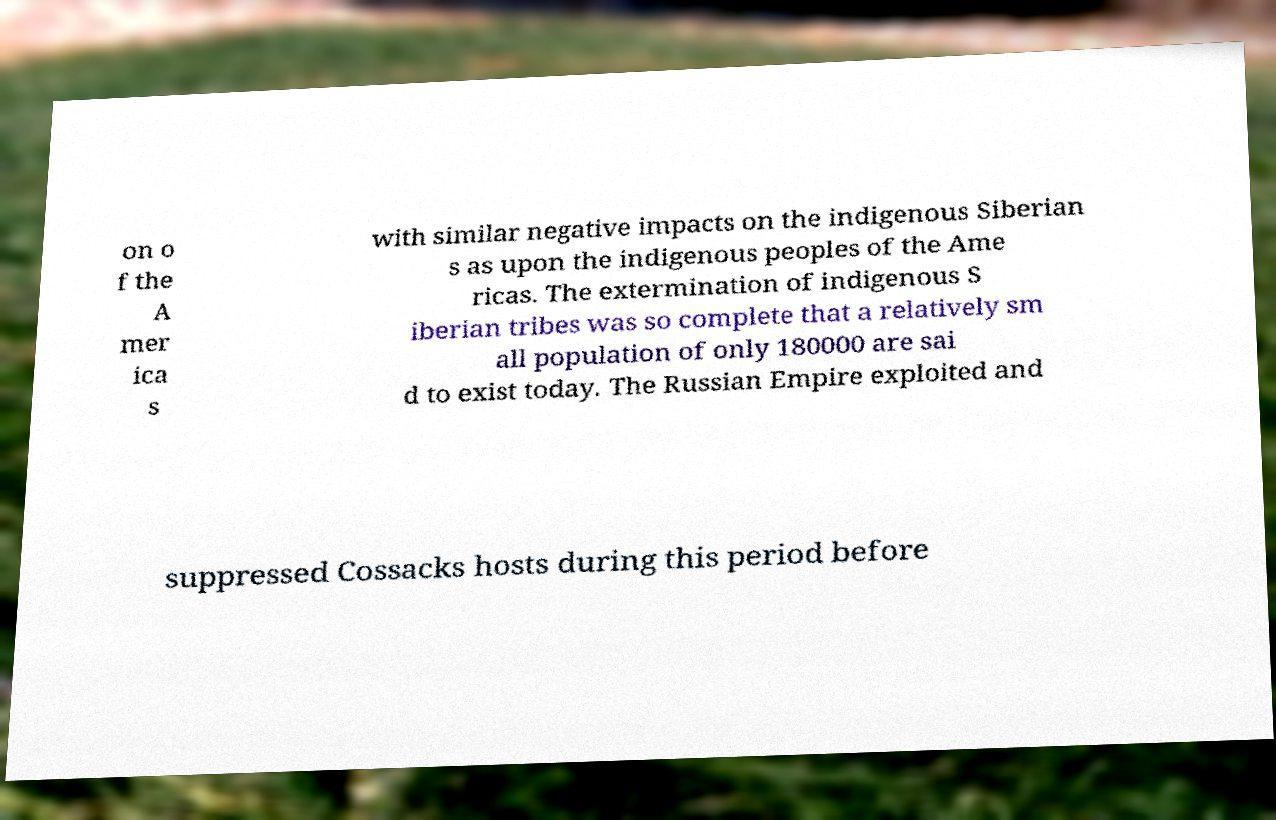Can you read and provide the text displayed in the image?This photo seems to have some interesting text. Can you extract and type it out for me? on o f the A mer ica s with similar negative impacts on the indigenous Siberian s as upon the indigenous peoples of the Ame ricas. The extermination of indigenous S iberian tribes was so complete that a relatively sm all population of only 180000 are sai d to exist today. The Russian Empire exploited and suppressed Cossacks hosts during this period before 